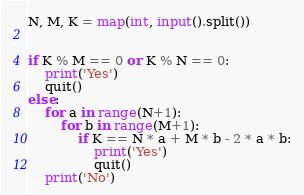Convert code to text. <code><loc_0><loc_0><loc_500><loc_500><_Python_>N, M, K = map(int, input().split())


if K % M == 0 or K % N == 0:
    print('Yes')
    quit()
else:
    for a in range(N+1):
        for b in range(M+1):
            if K == N * a + M * b - 2 * a * b:
                print('Yes')
                quit()
    print('No')</code> 